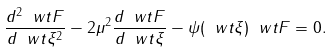Convert formula to latex. <formula><loc_0><loc_0><loc_500><loc_500>\frac { d ^ { 2 } \ w t { F } } { d \ w t \xi ^ { 2 } } - 2 \mu ^ { 2 } \frac { d \ w t { F } } { d \ w t \xi } - \psi ( \ w t \xi ) \ w t { F } = 0 .</formula> 